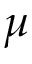Convert formula to latex. <formula><loc_0><loc_0><loc_500><loc_500>\mu</formula> 